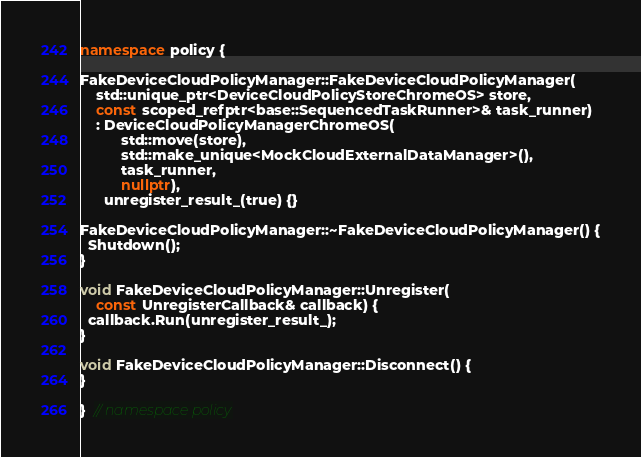<code> <loc_0><loc_0><loc_500><loc_500><_C++_>namespace policy {

FakeDeviceCloudPolicyManager::FakeDeviceCloudPolicyManager(
    std::unique_ptr<DeviceCloudPolicyStoreChromeOS> store,
    const scoped_refptr<base::SequencedTaskRunner>& task_runner)
    : DeviceCloudPolicyManagerChromeOS(
          std::move(store),
          std::make_unique<MockCloudExternalDataManager>(),
          task_runner,
          nullptr),
      unregister_result_(true) {}

FakeDeviceCloudPolicyManager::~FakeDeviceCloudPolicyManager() {
  Shutdown();
}

void FakeDeviceCloudPolicyManager::Unregister(
    const UnregisterCallback& callback) {
  callback.Run(unregister_result_);
}

void FakeDeviceCloudPolicyManager::Disconnect() {
}

}  // namespace policy
</code> 